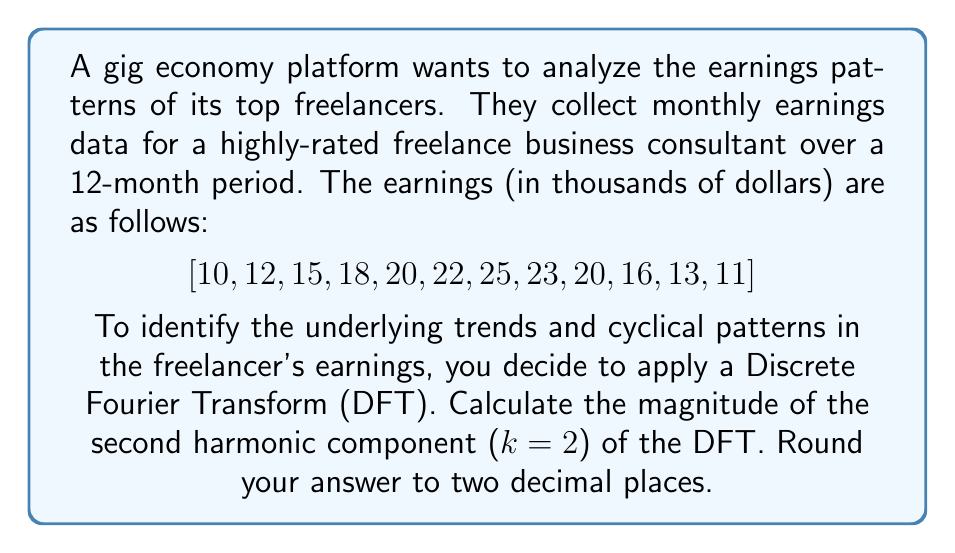What is the answer to this math problem? To solve this problem, we'll follow these steps:

1) The Discrete Fourier Transform (DFT) for a sequence of N points is given by:

   $$X_k = \sum_{n=0}^{N-1} x_n e^{-i2\pi kn/N}$$

   where $x_n$ are the input values, N is the number of points, and k is the harmonic we're calculating.

2) In this case, N = 12 (12 months of data), and we're asked to calculate for k = 2.

3) We can expand the formula using Euler's formula:

   $$X_k = \sum_{n=0}^{N-1} x_n [\cos(2\pi kn/N) - i\sin(2\pi kn/N)]$$

4) Let's calculate the real and imaginary parts separately:

   Real part: $$\text{Re}(X_2) = \sum_{n=0}^{11} x_n \cos(2\pi \cdot 2n/12)$$
   Imaginary part: $$\text{Im}(X_2) = -\sum_{n=0}^{11} x_n \sin(2\pi \cdot 2n/12)$$

5) Calculating these sums:

   $$\text{Re}(X_2) = 10(1) + 12(0.5) + 15(-0.5) + 18(-1) + 20(-0.5) + 22(0.5) + 25(1) + 23(0.5) + 20(-0.5) + 16(-1) + 13(-0.5) + 11(0.5) = -1.5$$

   $$\text{Im}(X_2) = -[10(0) + 12(0.866) + 15(0.866) + 18(0) + 20(-0.866) + 22(-0.866) + 25(0) + 23(0.866) + 20(0.866) + 16(0) + 13(-0.866) + 11(-0.866)] = -1.299$$

6) The magnitude of the second harmonic is given by:

   $$|X_2| = \sqrt{[\text{Re}(X_2)]^2 + [\text{Im}(X_2)]^2}$$

7) Plugging in our values:

   $$|X_2| = \sqrt{(-1.5)^2 + (-1.299)^2} = \sqrt{2.25 + 1.6874} = \sqrt{3.9374} = 1.9843$$

8) Rounding to two decimal places: 1.98
Answer: 1.98 